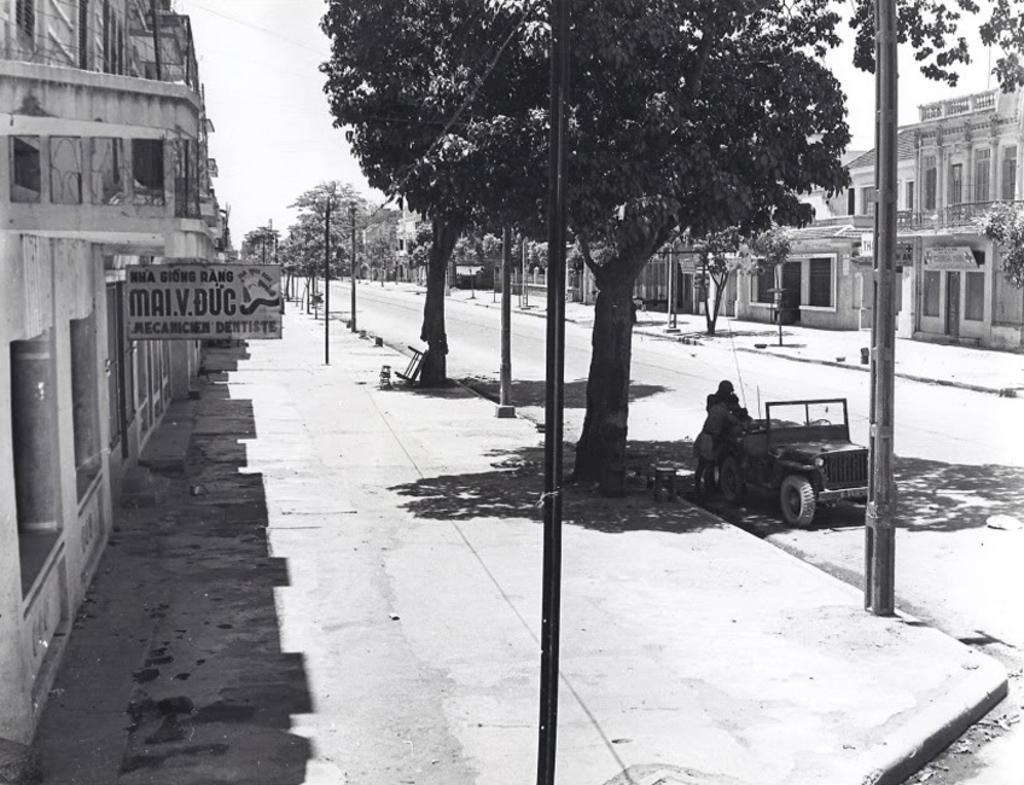What is the main subject of the image? There is a vehicle in the image. Can you describe the people in the image? There are two people standing on the road. What type of infrastructure is present in the image? Footpaths, poles, and buildings are visible in the image. What type of vegetation is present in the image? Trees are present in the image. What is the purpose of the name board in the image? The name board is present in the image to indicate a location or place. What is visible in the background of the image? The sky is visible in the background of the image. What type of straw is being used by the goose in the image? There is no goose or straw present in the image. What type of button is being used to fasten the vehicle in the image? There is no button present in the image, and vehicles are not fastened with buttons. 